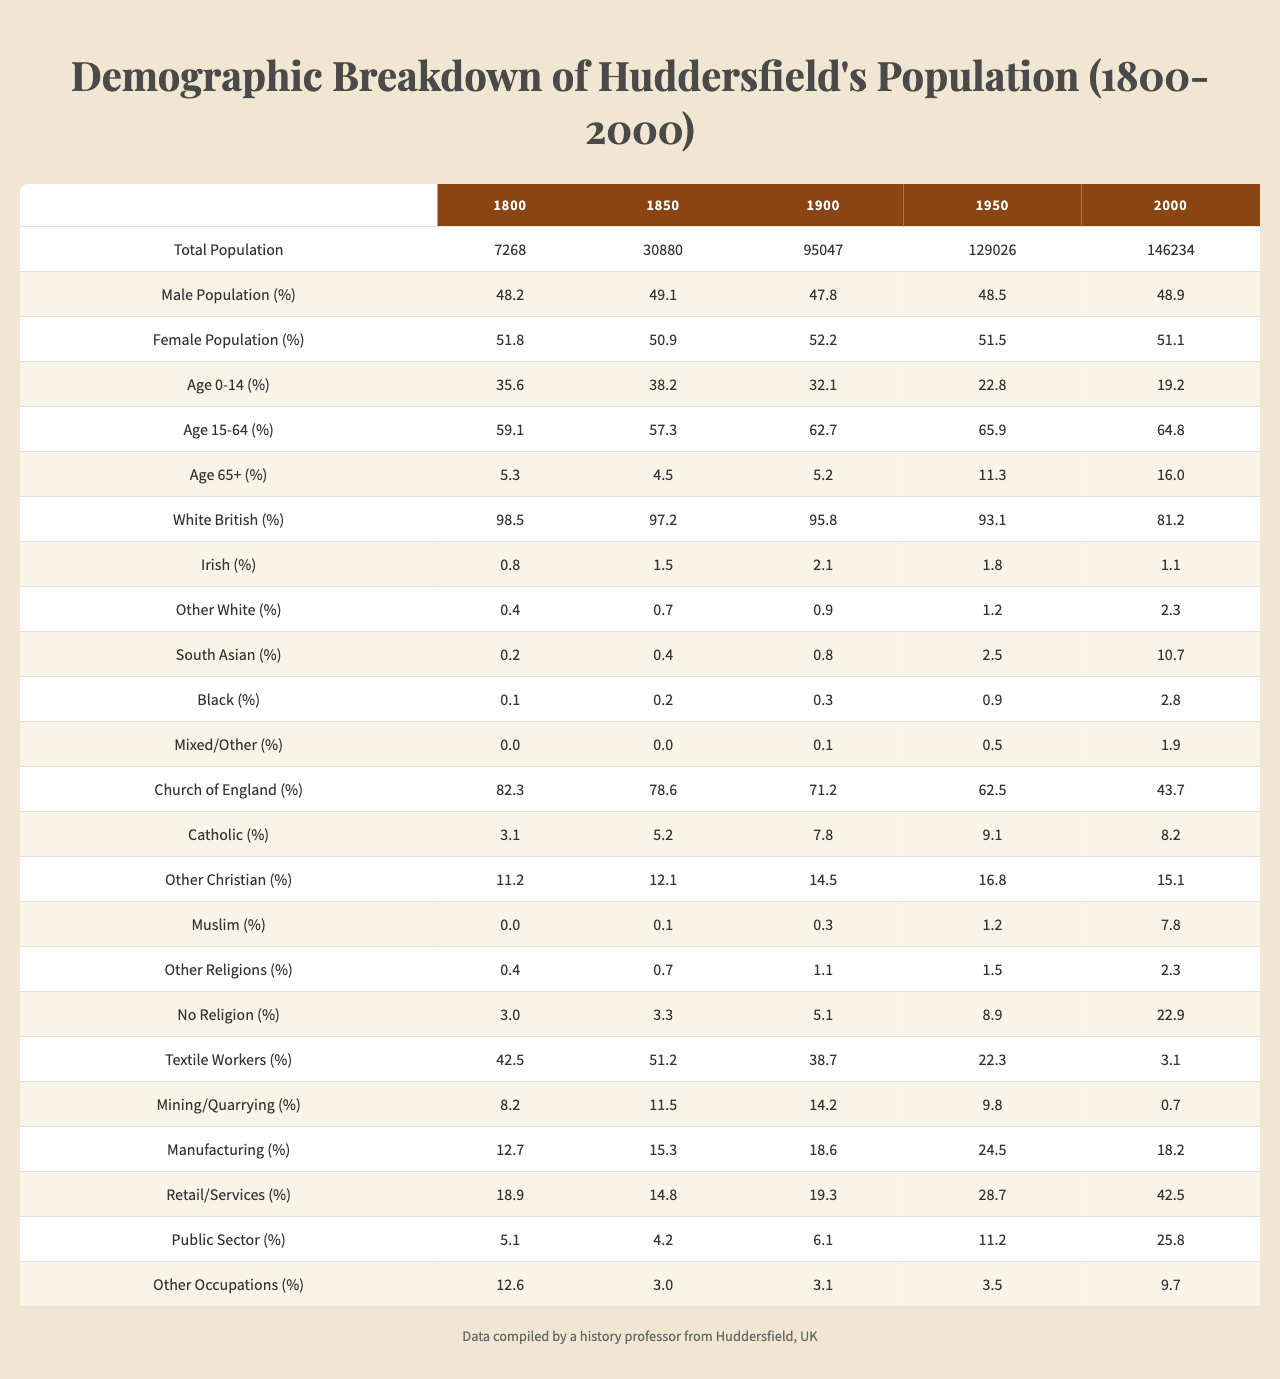What was the total population of Huddersfield in 1900? According to the table, the total population for Huddersfield in 1900 is explicitly listed under the "Total Population" column for that year, which shows the number 95047.
Answer: 95047 What percent of the population was aged 0-14 in 2000? In the 2000 row, the "Age 0-14 (%)" column indicates that 19.2% of Huddersfield's population was in the 0-14 age group.
Answer: 19.2% What was the total percentage of White British and Other White populations combined in 1950? To find the combined percentage, we add the "White British (%)" (93.1) and "Other White (%)" (1.2) for the year 1950, resulting in 93.1 + 1.2 = 94.3.
Answer: 94.3 Did the percentage of people with no religion increase from 1950 to 2000? The percentage of "No Religion (%)" in 1950 is 8.9%, while in 2000 it increases to 22.9%. Since 22.9 is greater than 8.9, we can conclude that there was indeed an increase.
Answer: Yes What was the difference in the percentage of Male Population between 1800 and 2000? We take the percentages from the "Male Population (%)" column for 1800 (48.2) and 2000 (48.9), and subtract: 48.9 - 48.2 = 0.7.
Answer: 0.7 In 1850, what percentage of the population worked in the Textile sector compared to the Public Sector? The "Textile Workers (%)" for 1850 is 51.2 and the "Public Sector (%)" is 4.2. The difference between them is calculated as 51.2 - 4.2 = 47.0.
Answer: 47.0 What was the percentage of South Asian individuals in Huddersfield in 2000, and how does it compare to its value in 1850? In 2000, the percentage of South Asian individuals is 10.7%, while in 1850 it is 0.4%. The percentage increased significantly from 0.4 to 10.7, indicating a rise in diversity.
Answer: Increased Was the Male Population percentage higher or lower than the Female Population percentage in 1900? The "Male Population (%)" for 1900 is 47.8%, and the "Female Population (%)" is 52.2%. Since 47.8 is less than 52.2, the Male Population percentage was lower.
Answer: Lower How much did the percentage of Church of England members decline from 1800 to 2000? We subtract the Church of England percentages for 1800 (82.3) and 2000 (43.7): 82.3 - 43.7 = 38.6, which indicates a significant decline over the period.
Answer: 38.6 What trend can be observed regarding the percentage of Textile Workers from 1800 to 2000? The percentage of "Textile Workers (%)" decreases from 42.5% in 1800 to 3.1% in 2000. This shows a significant decline in this occupation over two centuries.
Answer: Decrease 